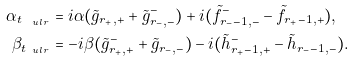<formula> <loc_0><loc_0><loc_500><loc_500>\alpha _ { t _ { \ u l r } } & = i \alpha ( \tilde { g } _ { r _ { + } , + } + \tilde { g } _ { r _ { - } , - } ^ { - } ) + i ( \tilde { f } _ { r _ { - } - 1 , - } ^ { - } - \tilde { f } _ { r _ { + } - 1 , + } ) , \\ \beta _ { t _ { \ u l r } } & = - i \beta ( \tilde { g } _ { r _ { + } , + } ^ { - } + \tilde { g } _ { r _ { - } , - } ) - i ( \tilde { h } _ { r _ { + } - 1 , + } ^ { - } - \tilde { h } _ { r _ { - } - 1 , - } ) .</formula> 